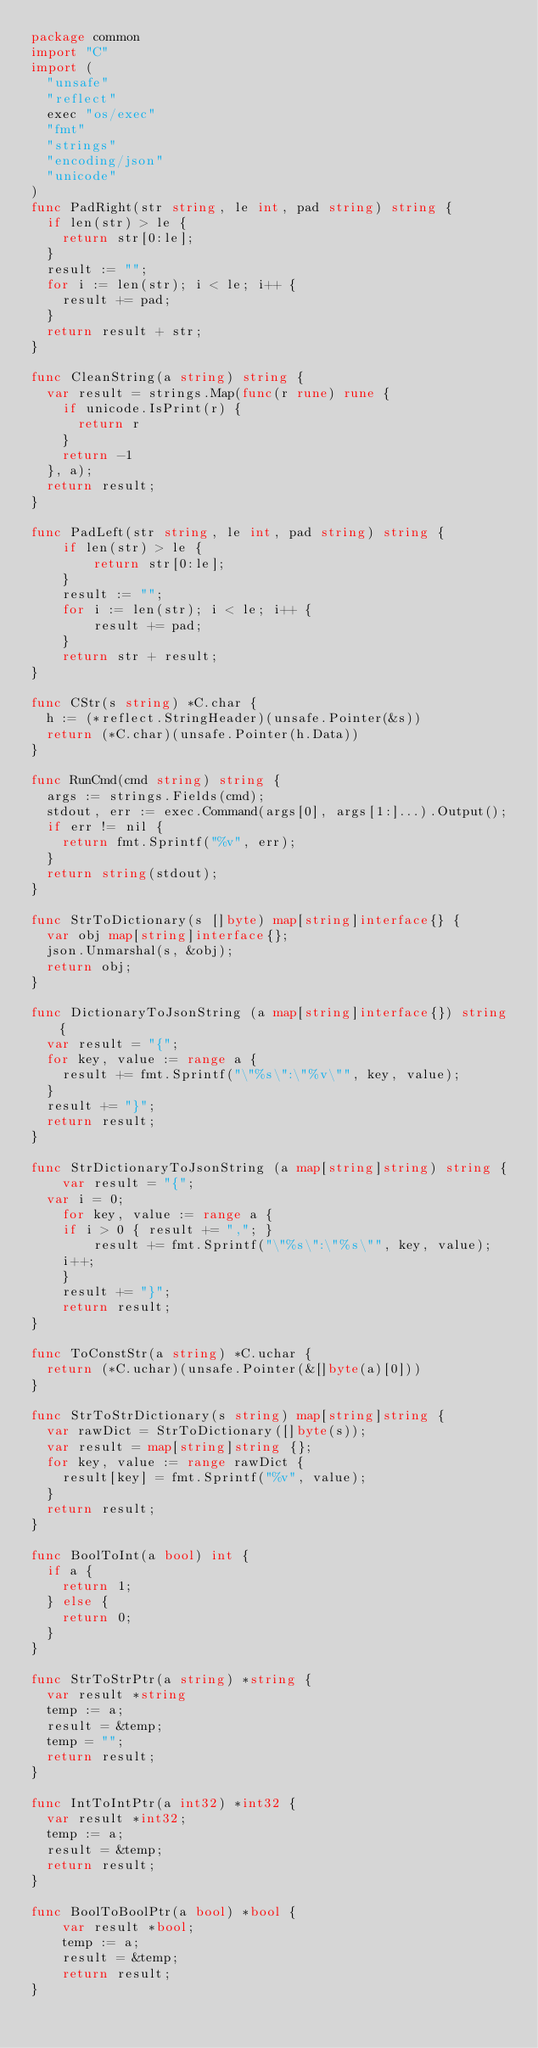<code> <loc_0><loc_0><loc_500><loc_500><_Go_>package common
import "C"
import (
	"unsafe"
	"reflect"
	exec "os/exec"
	"fmt"
	"strings"
	"encoding/json"
	"unicode"
)
func PadRight(str string, le int, pad string) string {
	if len(str) > le {
		return str[0:le];
	}
	result := "";
	for i := len(str); i < le; i++ {
		result += pad;
	}
	return result + str;
}

func CleanString(a string) string {
	var result = strings.Map(func(r rune) rune {
		if unicode.IsPrint(r) {
			return r
		}
		return -1
	}, a);
	return result;
}

func PadLeft(str string, le int, pad string) string {
    if len(str) > le {
        return str[0:le];
    }
    result := "";
    for i := len(str); i < le; i++ {
        result += pad;
    }
    return str + result;
}

func CStr(s string) *C.char {
	h := (*reflect.StringHeader)(unsafe.Pointer(&s))
	return (*C.char)(unsafe.Pointer(h.Data))
}

func RunCmd(cmd string) string {
	args := strings.Fields(cmd);
	stdout, err := exec.Command(args[0], args[1:]...).Output();
	if err != nil {
		return fmt.Sprintf("%v", err);
	}
	return string(stdout);
}

func StrToDictionary(s []byte) map[string]interface{} {
	var obj map[string]interface{};
	json.Unmarshal(s, &obj);
	return obj;
}

func DictionaryToJsonString (a map[string]interface{}) string {
	var result = "{";
	for key, value := range a {
		result += fmt.Sprintf("\"%s\":\"%v\"", key, value);
	}
	result += "}";
	return result;
}

func StrDictionaryToJsonString (a map[string]string) string {
    var result = "{";
	var i = 0;
    for key, value := range a {
		if i > 0 { result += ","; }
        result += fmt.Sprintf("\"%s\":\"%s\"", key, value);
		i++;
    }
    result += "}";
    return result;
}

func ToConstStr(a string) *C.uchar {
	return (*C.uchar)(unsafe.Pointer(&[]byte(a)[0]))
}

func StrToStrDictionary(s string) map[string]string {
	var rawDict = StrToDictionary([]byte(s));
	var result = map[string]string {};
	for key, value := range rawDict {
		result[key] = fmt.Sprintf("%v", value);
	}
	return result;
}

func BoolToInt(a bool) int {
	if a {
		return 1;
	} else {
		return 0;
	}
}

func StrToStrPtr(a string) *string {
	var result *string
	temp := a;
	result = &temp;
	temp = "";
	return result;
}

func IntToIntPtr(a int32) *int32 {
	var result *int32;
	temp := a;
	result = &temp;
	return result;
}

func BoolToBoolPtr(a bool) *bool {
    var result *bool;
    temp := a;
    result = &temp;
    return result;
}
</code> 